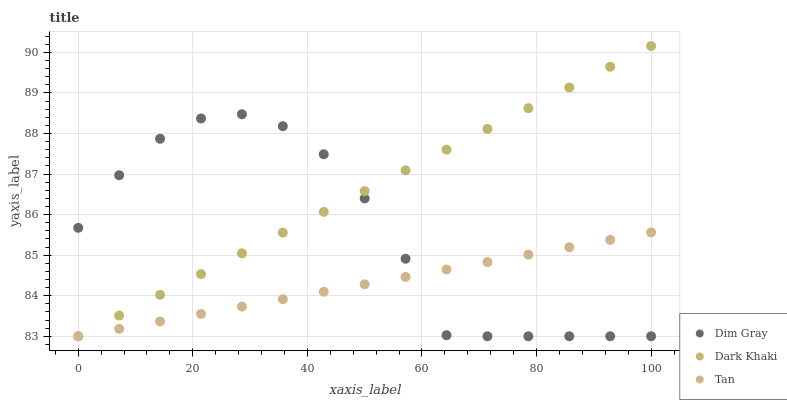Does Tan have the minimum area under the curve?
Answer yes or no. Yes. Does Dark Khaki have the maximum area under the curve?
Answer yes or no. Yes. Does Dim Gray have the minimum area under the curve?
Answer yes or no. No. Does Dim Gray have the maximum area under the curve?
Answer yes or no. No. Is Tan the smoothest?
Answer yes or no. Yes. Is Dim Gray the roughest?
Answer yes or no. Yes. Is Dim Gray the smoothest?
Answer yes or no. No. Is Tan the roughest?
Answer yes or no. No. Does Dark Khaki have the lowest value?
Answer yes or no. Yes. Does Dark Khaki have the highest value?
Answer yes or no. Yes. Does Dim Gray have the highest value?
Answer yes or no. No. Does Tan intersect Dim Gray?
Answer yes or no. Yes. Is Tan less than Dim Gray?
Answer yes or no. No. Is Tan greater than Dim Gray?
Answer yes or no. No. 